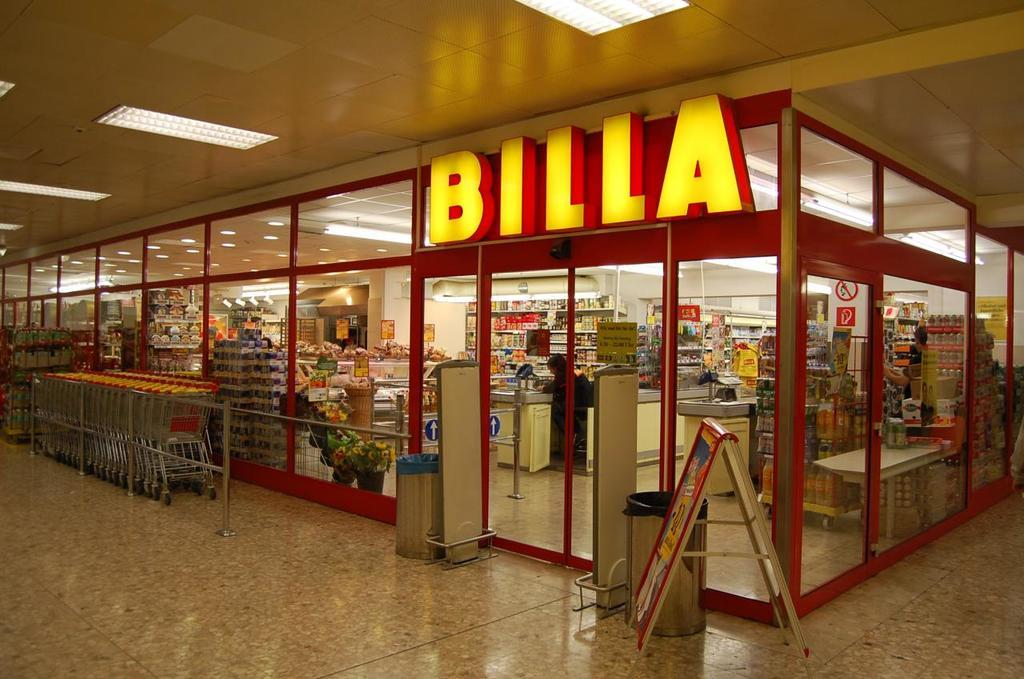<image>
Describe the image concisely. The entrance to the Billa grocery store has automatic doors that are closed. 